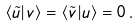Convert formula to latex. <formula><loc_0><loc_0><loc_500><loc_500>\langle \tilde { u } | v \rangle = \langle \tilde { v } | u \rangle = 0 \, .</formula> 